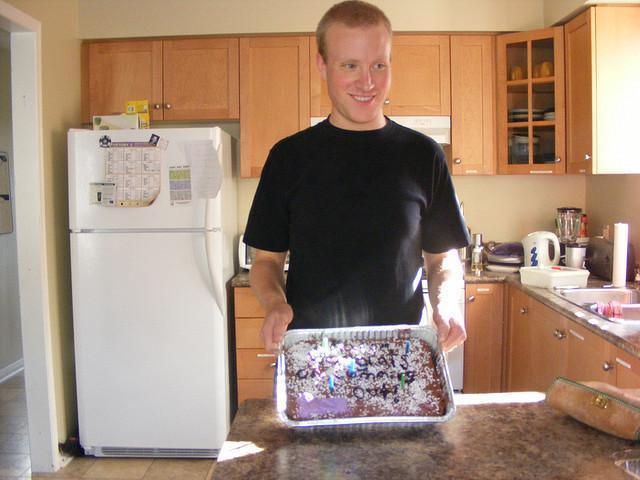How many handbags can you see?
Give a very brief answer. 1. How many sheep are in the photo?
Give a very brief answer. 0. 